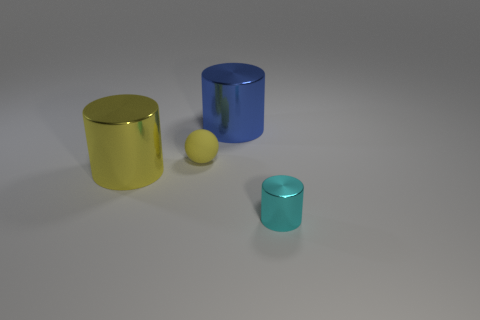There is a matte thing; does it have the same size as the cylinder on the left side of the tiny yellow object?
Ensure brevity in your answer.  No. What number of metallic cylinders have the same color as the tiny metallic object?
Offer a terse response. 0. What number of objects are either big cylinders or big cylinders that are behind the matte object?
Offer a very short reply. 2. Is the size of the cylinder behind the small yellow thing the same as the shiny object left of the big blue metal object?
Offer a very short reply. Yes. Is there another tiny ball that has the same material as the ball?
Provide a short and direct response. No. The small yellow object is what shape?
Make the answer very short. Sphere. There is a metal thing behind the thing that is to the left of the tiny rubber object; what is its shape?
Give a very brief answer. Cylinder. What number of other objects are the same shape as the small matte thing?
Offer a terse response. 0. What size is the yellow thing in front of the tiny thing behind the tiny metallic cylinder?
Give a very brief answer. Large. Are any tiny purple cylinders visible?
Keep it short and to the point. No. 